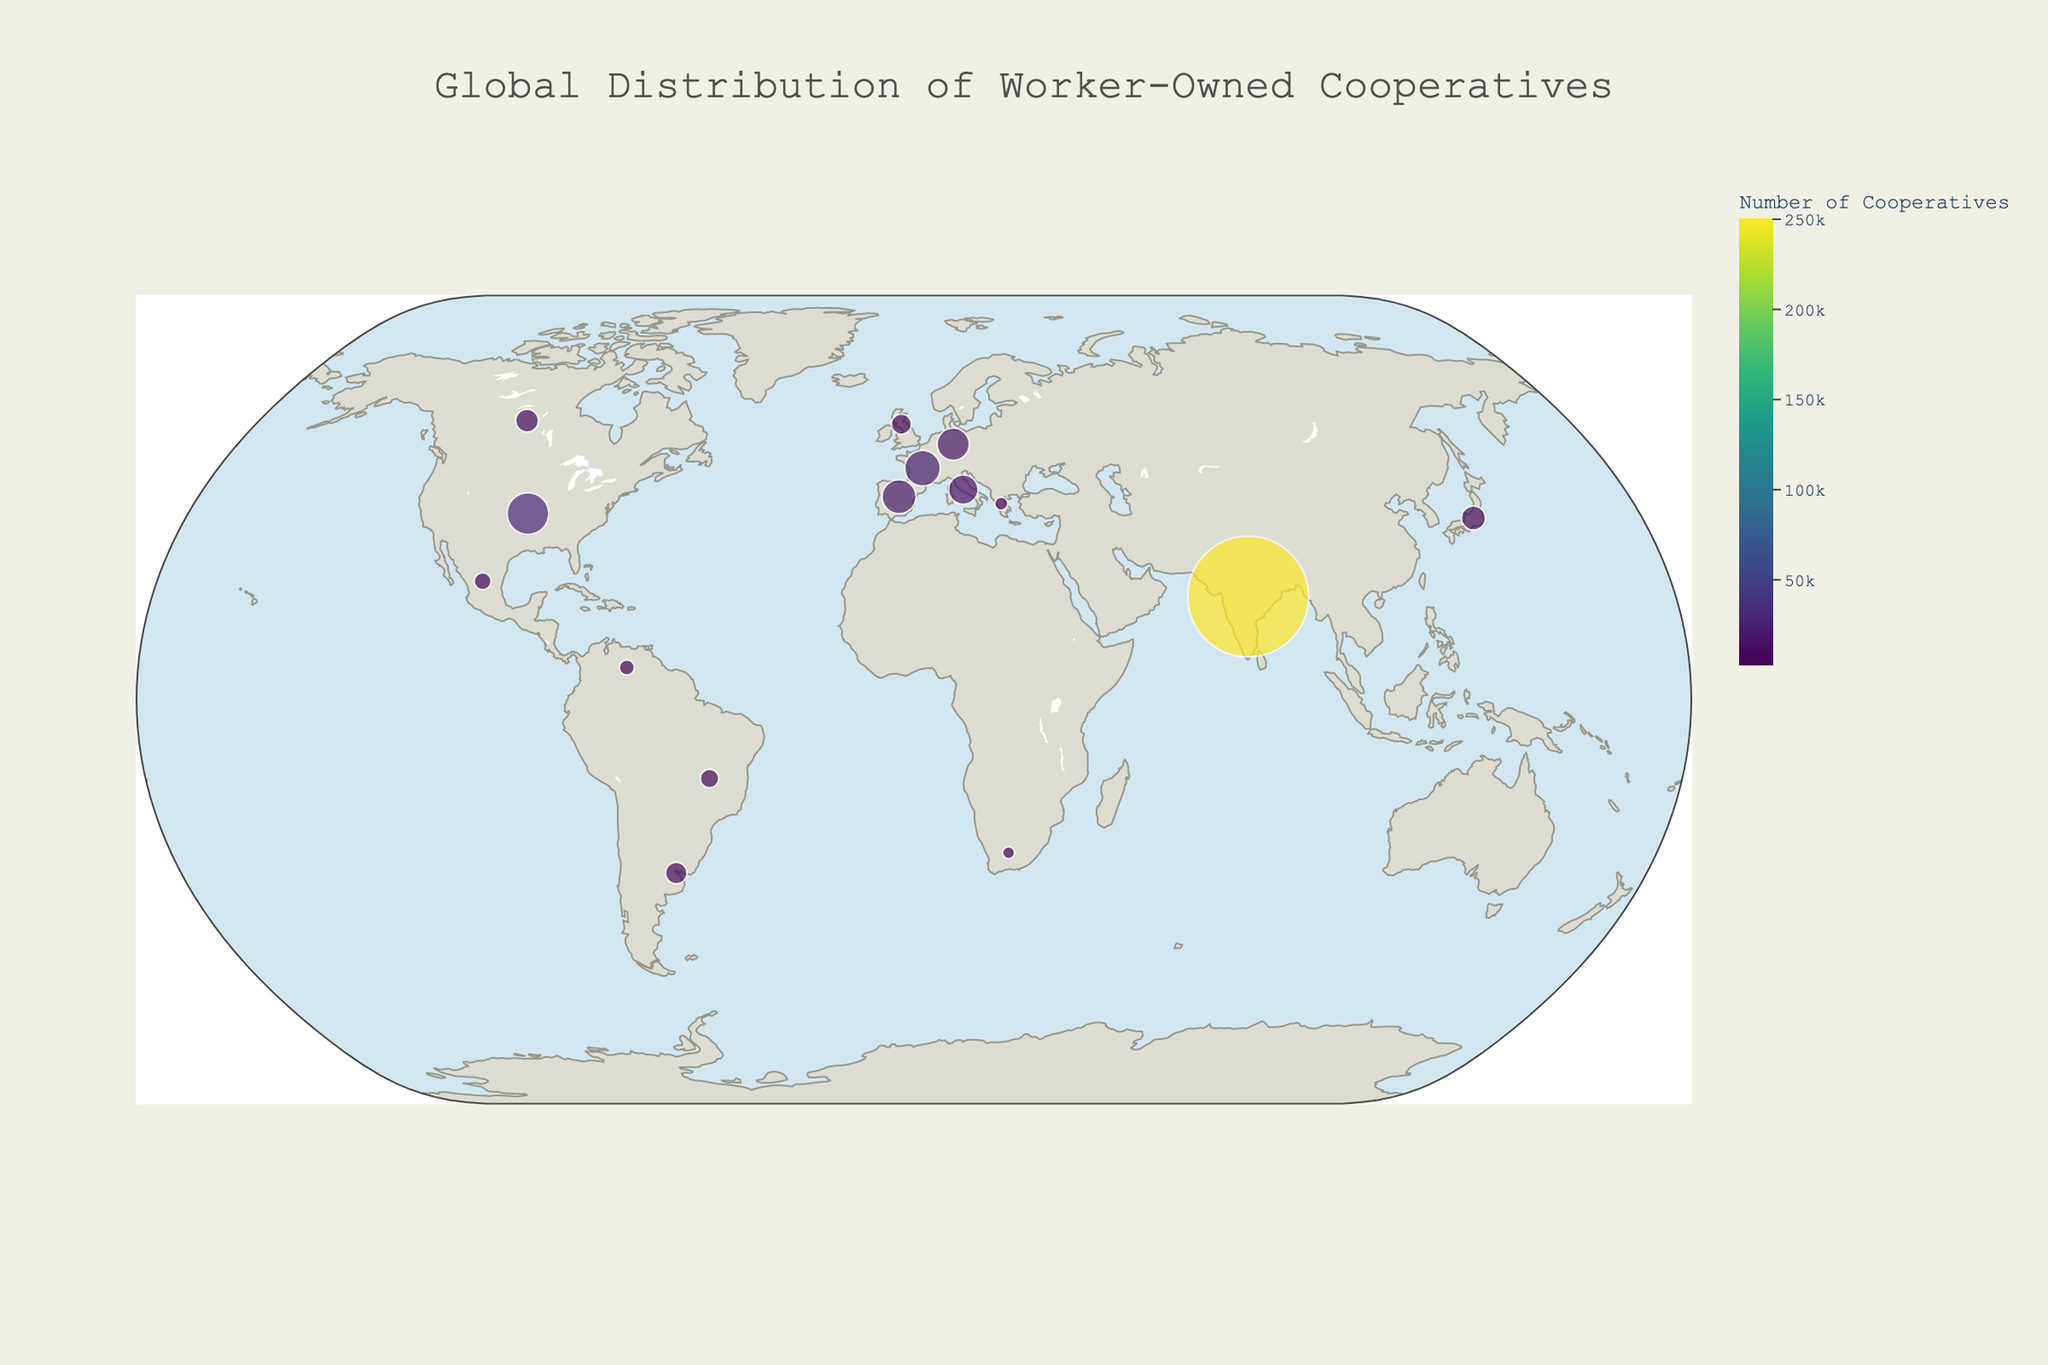Which country has the highest number of worker-owned cooperatives? The figure shows the number of cooperatives represented by the size of the dots. The largest dot corresponds to India.
Answer: India What's the title of the figure? The title is displayed at the top center of the figure.
Answer: Global Distribution of Worker-Owned Cooperatives How many countries have more than 10,000 cooperatives? The figure displays the number of cooperatives as the size of the dots. Countries with more than 10,000 cooperatives include the United States, Japan, Germany, France, Italy, Spain, and India.
Answer: 7 Which country has a prominent example named "Mondragón Corporation"? Hovering over Spain will reveal its prominent example.
Answer: Spain What is the number of cooperatives in Brazil and Venezuela combined? Looking at the sizes of the dots over Brazil and Venezuela, the numbers are 6,000 and 4,000, respectively. Adding these gives 6000 + 4000 = 10,000.
Answer: 10,000 Which country has fewer cooperatives, Argentina or Mexico? The figure shows that Argentina has 8,000 cooperatives and Mexico has 5,000 cooperatives. Mexico has fewer cooperatives.
Answer: Mexico Which countries are located in the southern hemisphere? By observing the geographic plot, countries in the southern hemisphere include Argentina, Brazil, South Africa, and Venezuela.
Answer: Argentina, Brazil, South Africa, Venezuela What is the prominent example in the United Kingdom? Hovering over the United Kingdom will reveal its prominent example.
Answer: Suma Wholefoods How does the number of cooperatives in Canada compare to those in Japan? Canada has 9,000 cooperatives, while Japan has 10,000 cooperatives. Japan has more cooperatives than Canada.
Answer: Japan has more cooperatives Based on the color scale, which countries show high densities of cooperatives? The color intensity on the dots signifies higher densities. The darkest colored dots belong to India, followed by countries like the United States, France, Spain, and others with larger numbers.
Answer: India, United States, France, Spain 